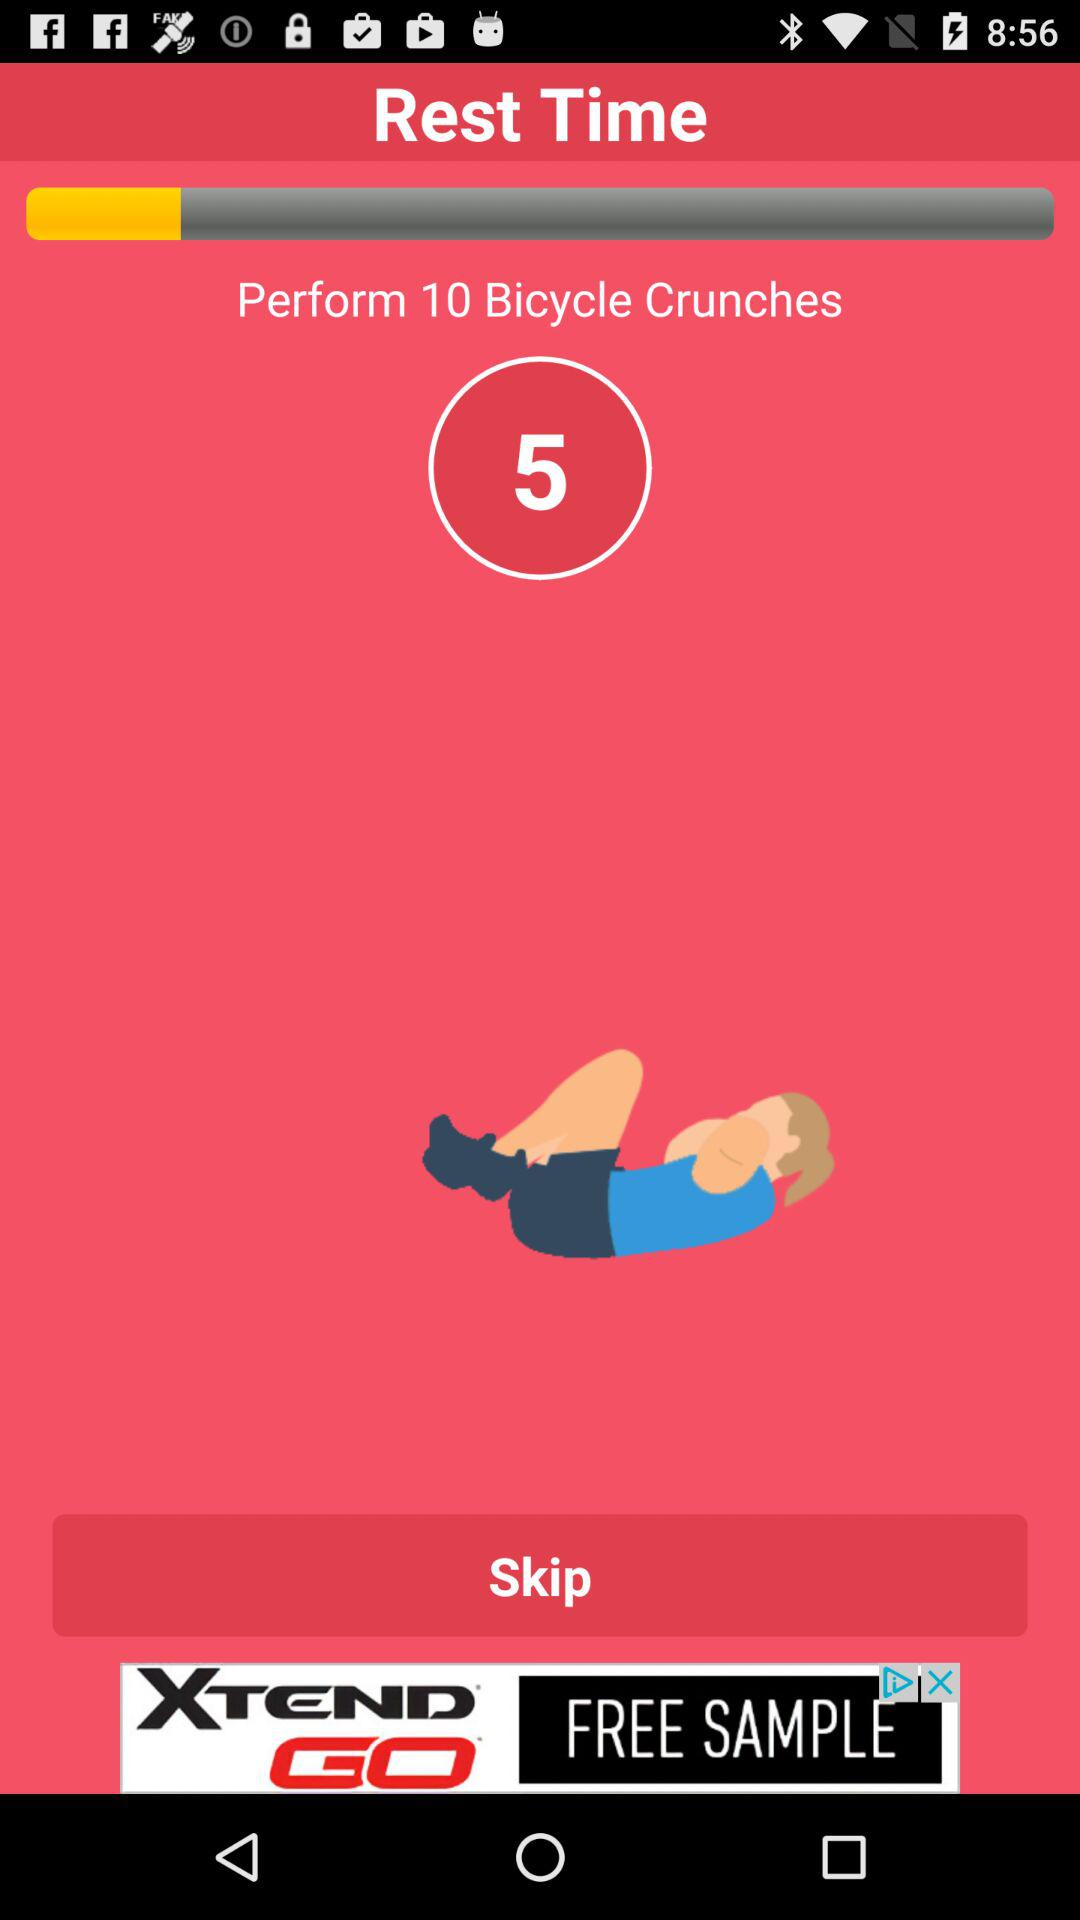What is the selected rest time?
When the provided information is insufficient, respond with <no answer>. <no answer> 